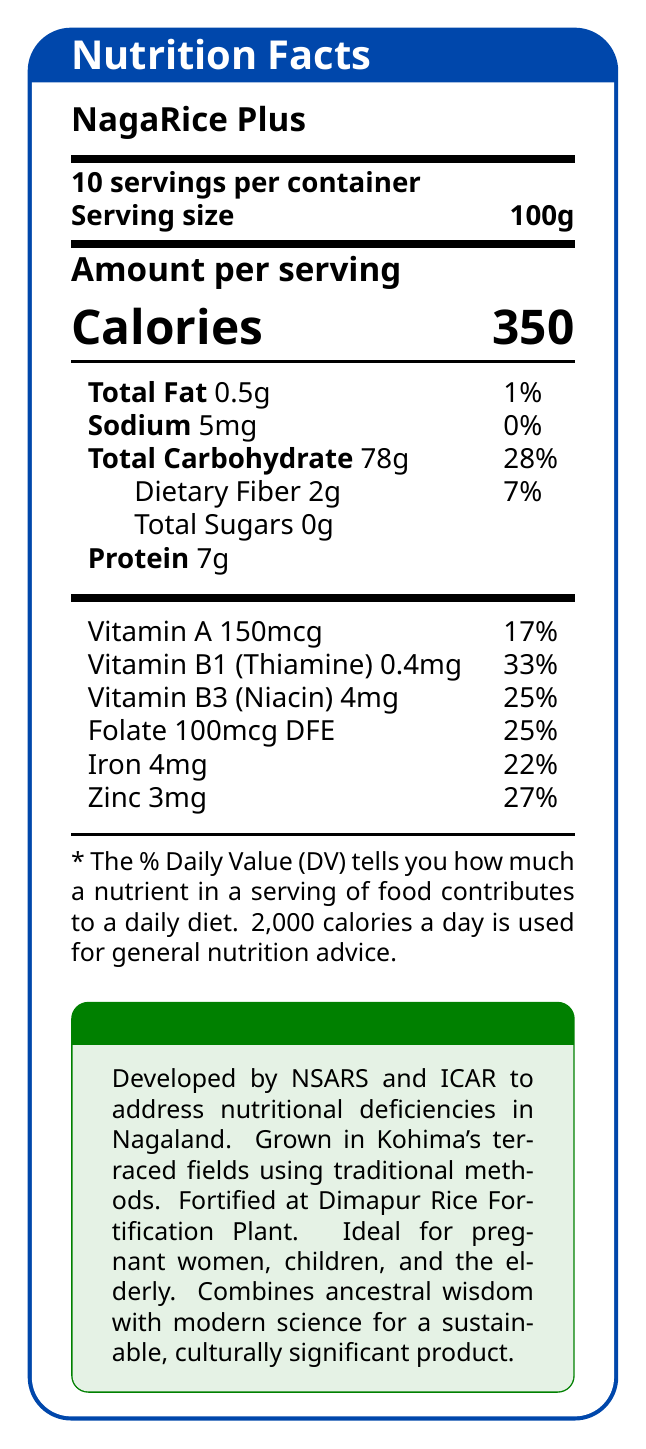What is the serving size of NagaRice Plus? The document lists the serving size as "100g."
Answer: 100g How many servings are there per container of NagaRice Plus? The document specifies "10 servings per container."
Answer: 10 How many calories are in one serving of NagaRice Plus? The document shows "Calories 350" for one serving.
Answer: 350 What amounts of Total Fat and Sodium are present in each serving of NagaRice Plus? The document lists "Total Fat 0.5g" and "Sodium 5mg" in the nutritional profile.
Answer: 0.5g Total Fat and 5mg Sodium How much protein is in one serving of NagaRice Plus? The document shows there are "Protein 7g" per serving.
Answer: 7g Which vitamin contributes the highest percentage to the Daily Value (DV) in NagaRice Plus?
A. Vitamin A
B. Vitamin B1 (Thiamine)
C. Folate
D. Iron Vitamin B1 (Thiamine) contributes 33% to the DV, which is the highest among the listed vitamins and minerals.
Answer: B. Vitamin B1 (Thiamine) What is the main purpose of developing NagaRice Plus? 
A. To replace all traditional rice varieties in Nagaland
B. To provide a fortified rice option that addresses nutritional deficiencies 
C. To export it internationally
D. To use it as animal feed The additional info section explains that NagaRice Plus was developed to address common nutritional deficiencies found in Nagaland.
Answer: B. To provide a fortified rice option that addresses nutritional deficiencies True or False: NagaRice Plus contains added sugars. The document states "Total Sugars 0g," indicating no added sugars.
Answer: False Briefly summarize the main idea of the document. The document describes the nutritional profile, cultivation methods, target audience, and cultural significance of NagaRice Plus.
Answer: NagaRice Plus is a fortified rice variety developed to address common nutritional deficiencies in Nagaland. It is particularly beneficial for pregnant women, children, and the elderly. The product combines traditional Naga farming methods with modern fortification techniques and supports local farmers while promoting food security. Who are the primary beneficiaries of NagaRice Plus according to the document? The additional information states that NagaRice Plus is particularly beneficial for pregnant women, children, and the elderly.
Answer: Pregnant women, children, and the elderly in Nagaland Where is NagaRice Plus milled and fortified? The additional info section mentions that the rice is milled and fortified at the Dimapur Rice Fortification Plant.
Answer: At the Dimapur Rice Fortification Plant How much Folate does one serving of NagaRice Plus contain? The document lists "Folate 100mcg DFE" in the vitamins and minerals section.
Answer: 100mcg DFE Can we determine the price of NagaRice Plus from the document? The document does not provide any details about the price of NagaRice Plus.
Answer: Not enough information Describe the cultivation methods used for NagaRice Plus. The additional information specifies that NagaRice Plus is grown using traditional Naga farming methods in the terraced fields of Kohima district.
Answer: Traditional Naga farming methods in the terraced fields of Kohima district 